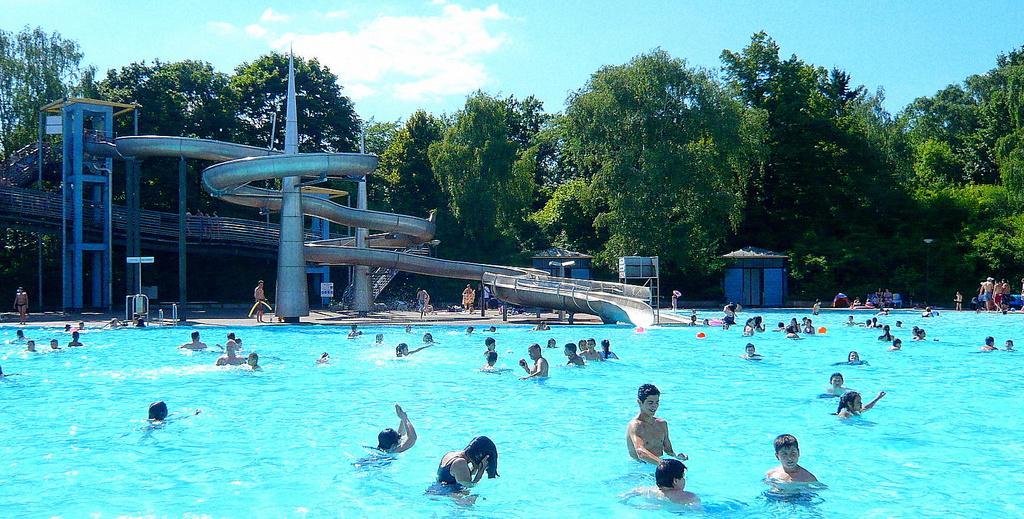Could you give a brief overview of what you see in this image? In the image there is a pool with many swimming in it,on the left side there is a water slide followed by trees in the background all over the image and above its sky with cloud. 